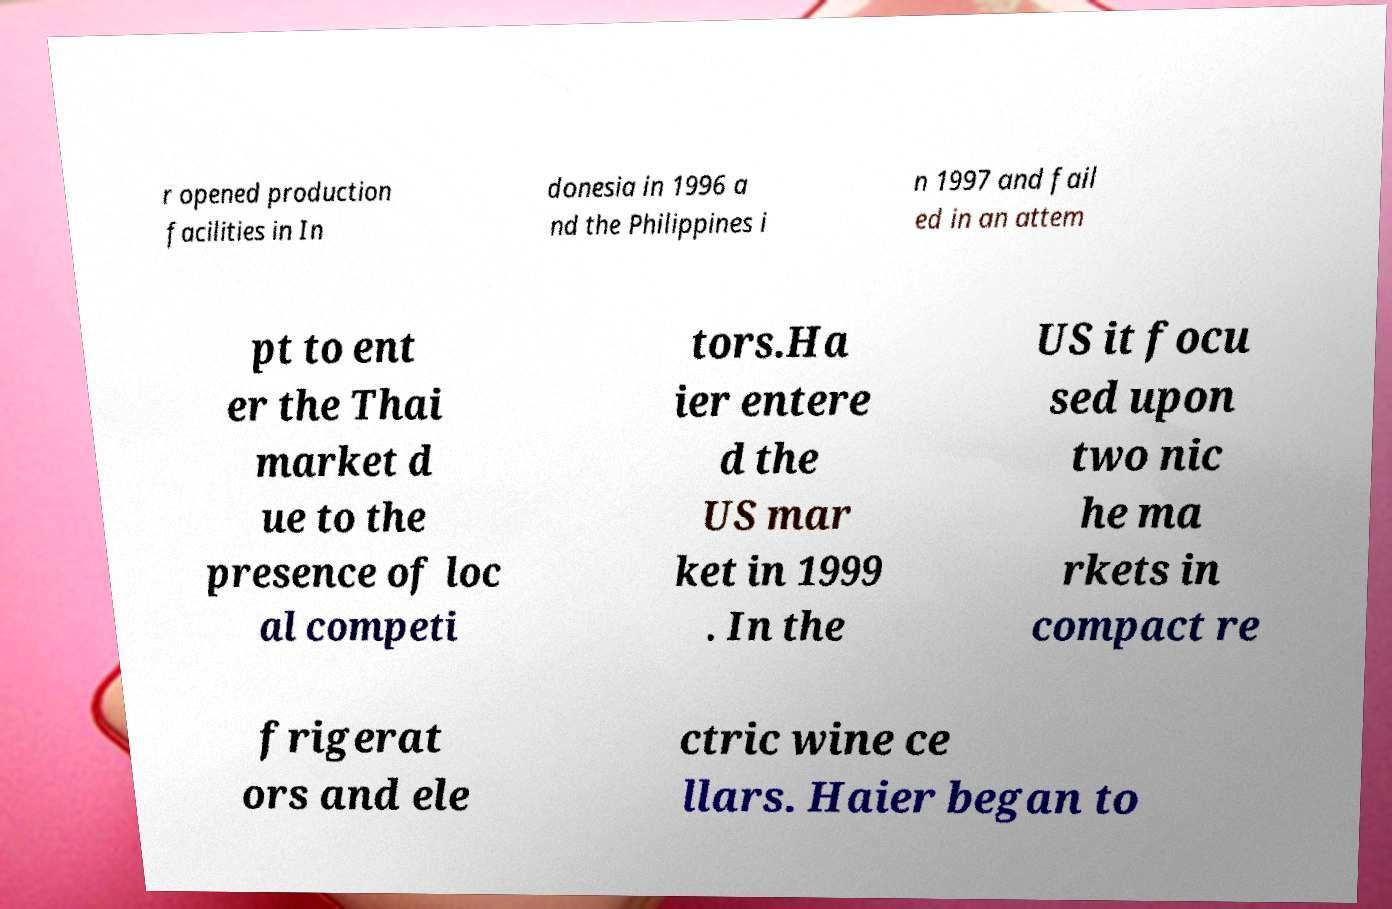What messages or text are displayed in this image? I need them in a readable, typed format. r opened production facilities in In donesia in 1996 a nd the Philippines i n 1997 and fail ed in an attem pt to ent er the Thai market d ue to the presence of loc al competi tors.Ha ier entere d the US mar ket in 1999 . In the US it focu sed upon two nic he ma rkets in compact re frigerat ors and ele ctric wine ce llars. Haier began to 